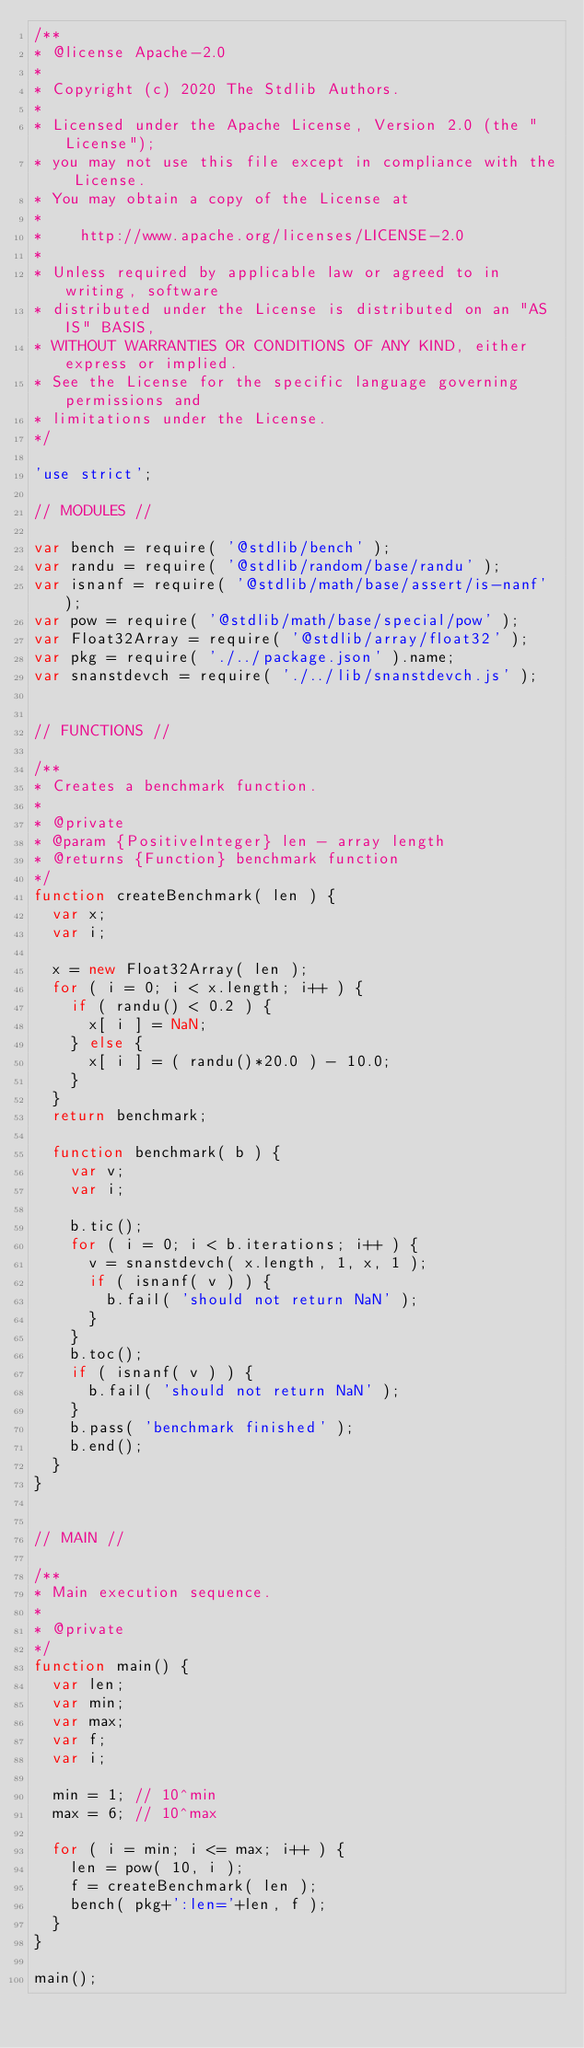<code> <loc_0><loc_0><loc_500><loc_500><_JavaScript_>/**
* @license Apache-2.0
*
* Copyright (c) 2020 The Stdlib Authors.
*
* Licensed under the Apache License, Version 2.0 (the "License");
* you may not use this file except in compliance with the License.
* You may obtain a copy of the License at
*
*    http://www.apache.org/licenses/LICENSE-2.0
*
* Unless required by applicable law or agreed to in writing, software
* distributed under the License is distributed on an "AS IS" BASIS,
* WITHOUT WARRANTIES OR CONDITIONS OF ANY KIND, either express or implied.
* See the License for the specific language governing permissions and
* limitations under the License.
*/

'use strict';

// MODULES //

var bench = require( '@stdlib/bench' );
var randu = require( '@stdlib/random/base/randu' );
var isnanf = require( '@stdlib/math/base/assert/is-nanf' );
var pow = require( '@stdlib/math/base/special/pow' );
var Float32Array = require( '@stdlib/array/float32' );
var pkg = require( './../package.json' ).name;
var snanstdevch = require( './../lib/snanstdevch.js' );


// FUNCTIONS //

/**
* Creates a benchmark function.
*
* @private
* @param {PositiveInteger} len - array length
* @returns {Function} benchmark function
*/
function createBenchmark( len ) {
	var x;
	var i;

	x = new Float32Array( len );
	for ( i = 0; i < x.length; i++ ) {
		if ( randu() < 0.2 ) {
			x[ i ] = NaN;
		} else {
			x[ i ] = ( randu()*20.0 ) - 10.0;
		}
	}
	return benchmark;

	function benchmark( b ) {
		var v;
		var i;

		b.tic();
		for ( i = 0; i < b.iterations; i++ ) {
			v = snanstdevch( x.length, 1, x, 1 );
			if ( isnanf( v ) ) {
				b.fail( 'should not return NaN' );
			}
		}
		b.toc();
		if ( isnanf( v ) ) {
			b.fail( 'should not return NaN' );
		}
		b.pass( 'benchmark finished' );
		b.end();
	}
}


// MAIN //

/**
* Main execution sequence.
*
* @private
*/
function main() {
	var len;
	var min;
	var max;
	var f;
	var i;

	min = 1; // 10^min
	max = 6; // 10^max

	for ( i = min; i <= max; i++ ) {
		len = pow( 10, i );
		f = createBenchmark( len );
		bench( pkg+':len='+len, f );
	}
}

main();
</code> 